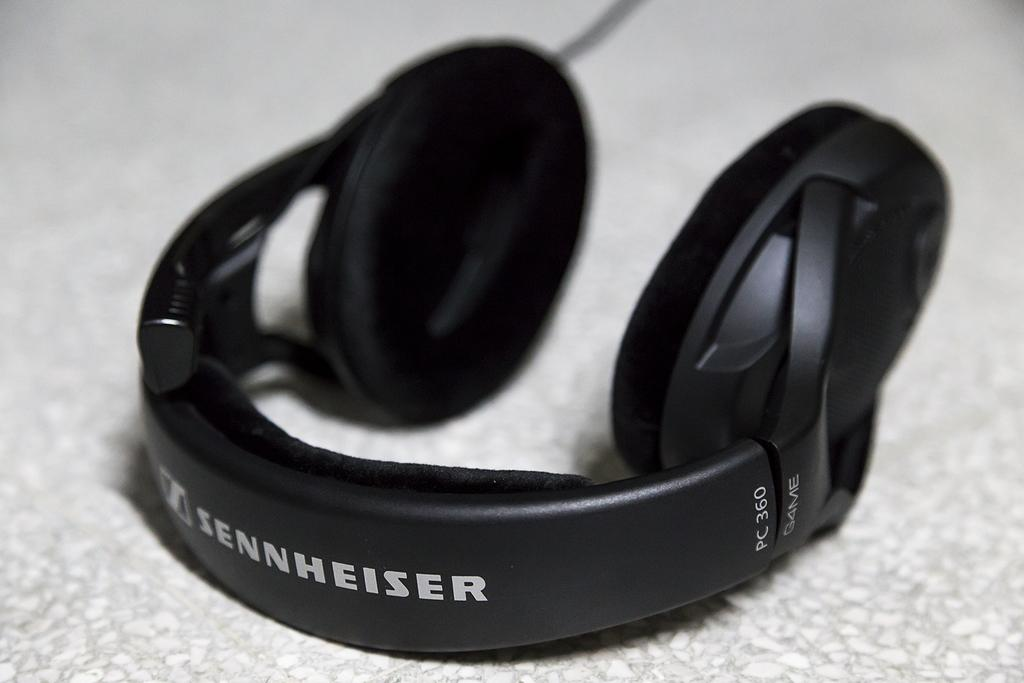What type of audio equipment is in the image? There is a black color headphone in the image. What is the color of the surface the headphone is placed on? The headphone is on a white color surface. Is there any text or branding on the headphone? Yes, there is writing on the headphone. Can you hear the sound of thunder in the image? There is no sound or audio source in the image, so it is not possible to hear any thunder. Is there a stamp on the headphone? There is no mention of a stamp on the headphone in the provided facts, so it cannot be confirmed or denied. 